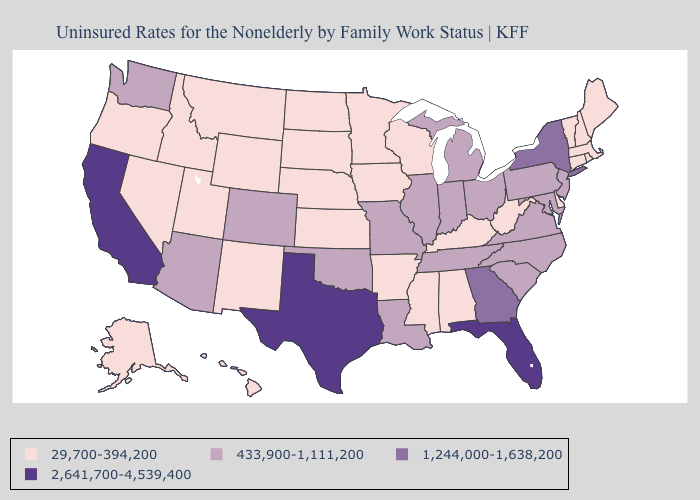Among the states that border New Hampshire , which have the lowest value?
Keep it brief. Maine, Massachusetts, Vermont. What is the value of Idaho?
Concise answer only. 29,700-394,200. Does the first symbol in the legend represent the smallest category?
Quick response, please. Yes. What is the value of Wyoming?
Quick response, please. 29,700-394,200. What is the value of Wisconsin?
Give a very brief answer. 29,700-394,200. Is the legend a continuous bar?
Be succinct. No. What is the highest value in the USA?
Answer briefly. 2,641,700-4,539,400. What is the value of Alabama?
Short answer required. 29,700-394,200. Name the states that have a value in the range 2,641,700-4,539,400?
Answer briefly. California, Florida, Texas. What is the lowest value in the Northeast?
Short answer required. 29,700-394,200. Name the states that have a value in the range 1,244,000-1,638,200?
Short answer required. Georgia, New York. What is the value of Oregon?
Concise answer only. 29,700-394,200. Which states have the highest value in the USA?
Keep it brief. California, Florida, Texas. Does the first symbol in the legend represent the smallest category?
Short answer required. Yes. 